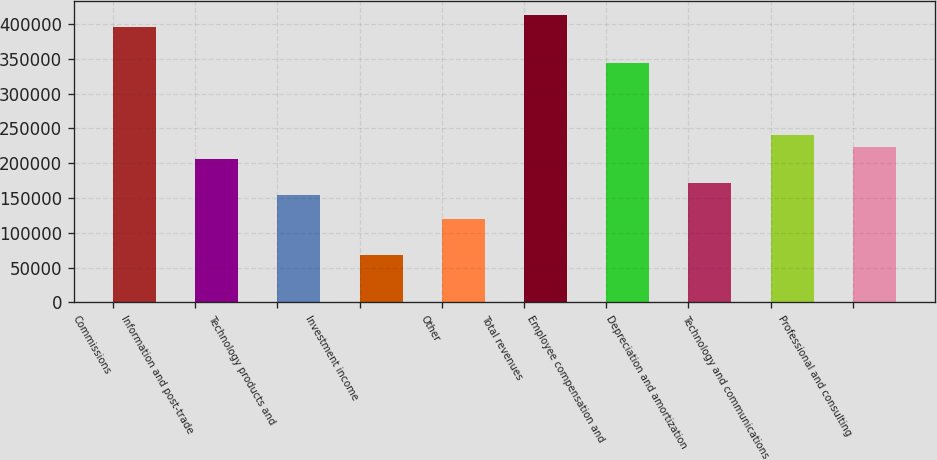Convert chart. <chart><loc_0><loc_0><loc_500><loc_500><bar_chart><fcel>Commissions<fcel>Information and post-trade<fcel>Technology products and<fcel>Investment income<fcel>Other<fcel>Total revenues<fcel>Employee compensation and<fcel>Depreciation and amortization<fcel>Technology and communications<fcel>Professional and consulting<nl><fcel>395310<fcel>206249<fcel>154687<fcel>68749.6<fcel>120312<fcel>412497<fcel>343748<fcel>171874<fcel>240624<fcel>223436<nl></chart> 